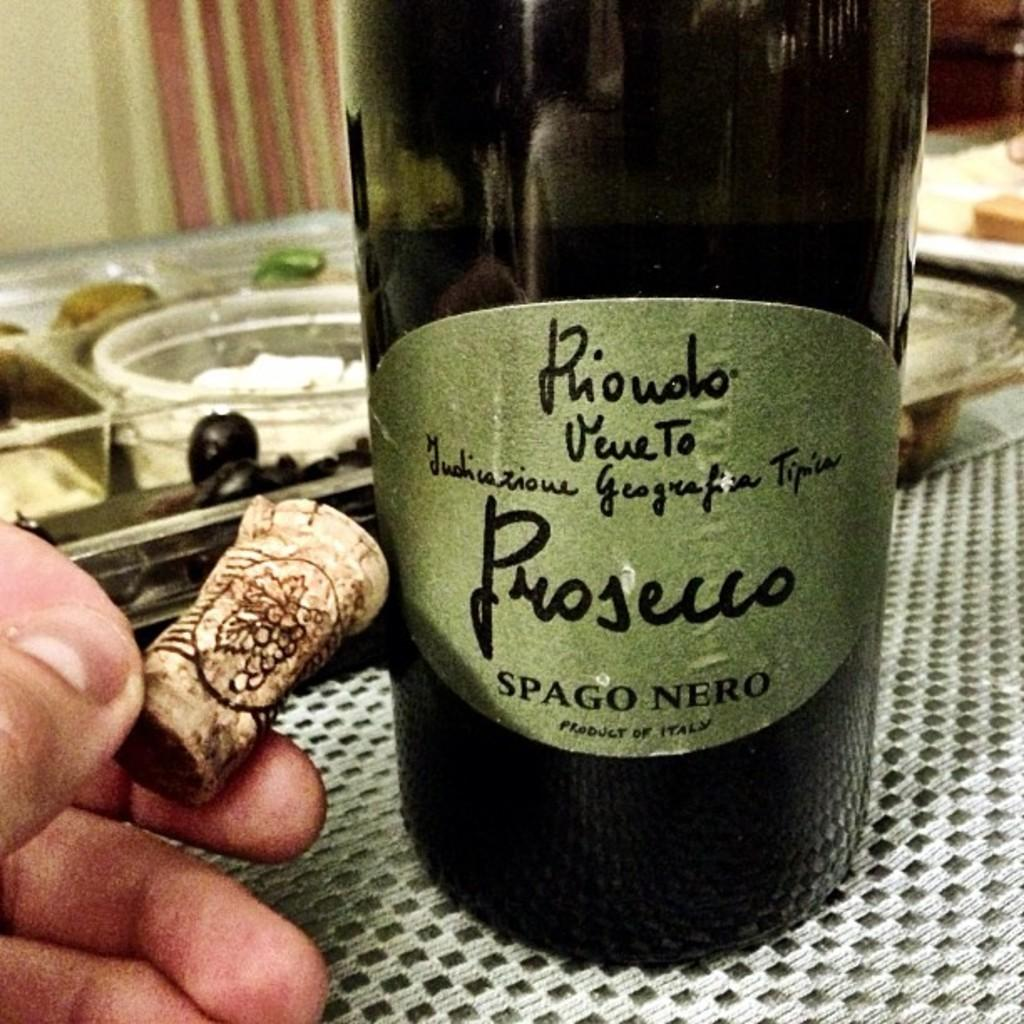What is the main object in the image? There is a wine bottle in the image. Can you describe the person in the image? There is a person in the image. What is the person holding in their hand? The person is holding a cork in their hand. What type of grass is growing around the person in the image? There is no grass visible in the image. How many people from the company are present in the image? The provided facts do not mention any company or the number of people present. 